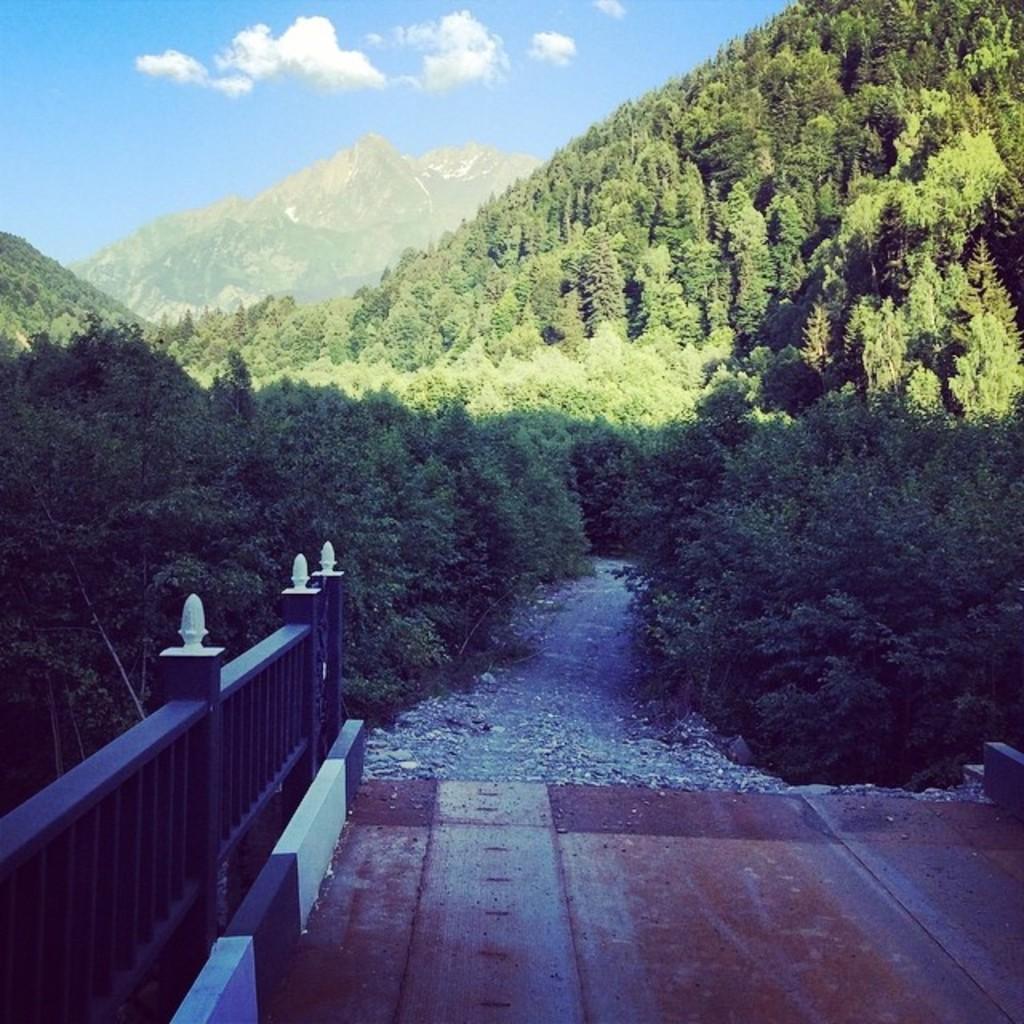Please provide a concise description of this image. This picture is clicked outside. In the foreground we can see an object and the metal fence. In the center we can see the path, trees, plants. In the background we can see the sky and the hills. 